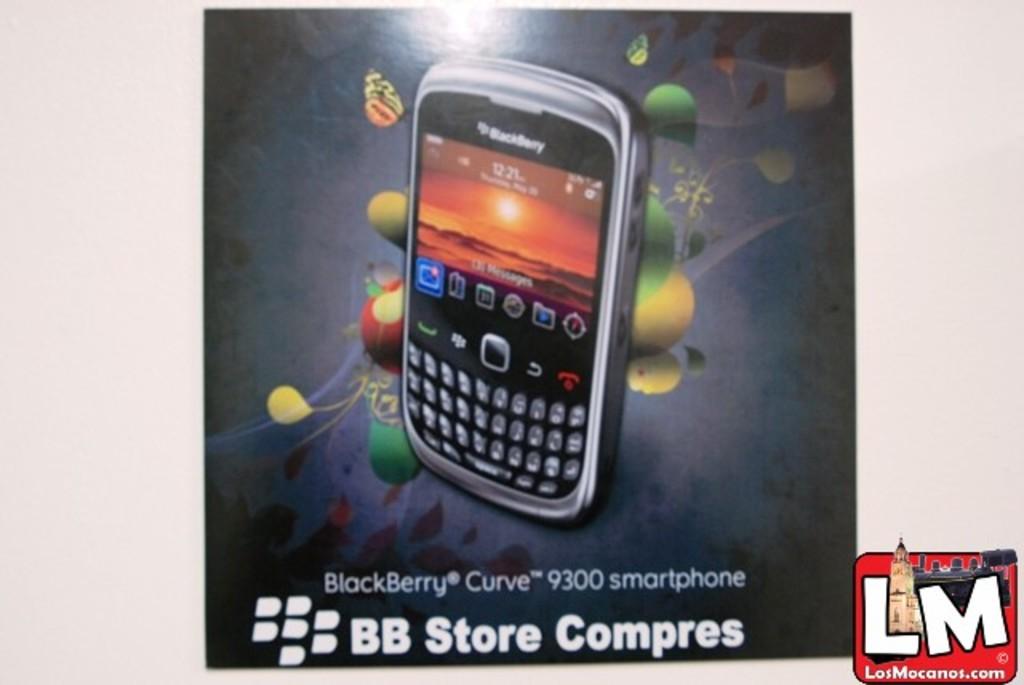What type of phone is this?
Offer a terse response. Blackberry. What kind of phone is this?
Ensure brevity in your answer.  Blackberry. 